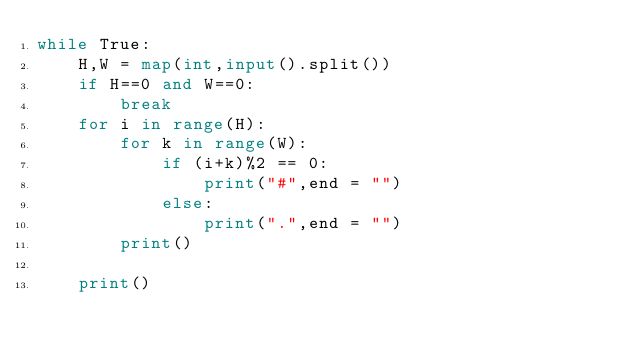Convert code to text. <code><loc_0><loc_0><loc_500><loc_500><_Python_>while True:
    H,W = map(int,input().split())
    if H==0 and W==0:
        break
    for i in range(H):
        for k in range(W):
            if (i+k)%2 == 0:
                print("#",end = "")
            else:
                print(".",end = "")
        print()
        
    print()
</code> 